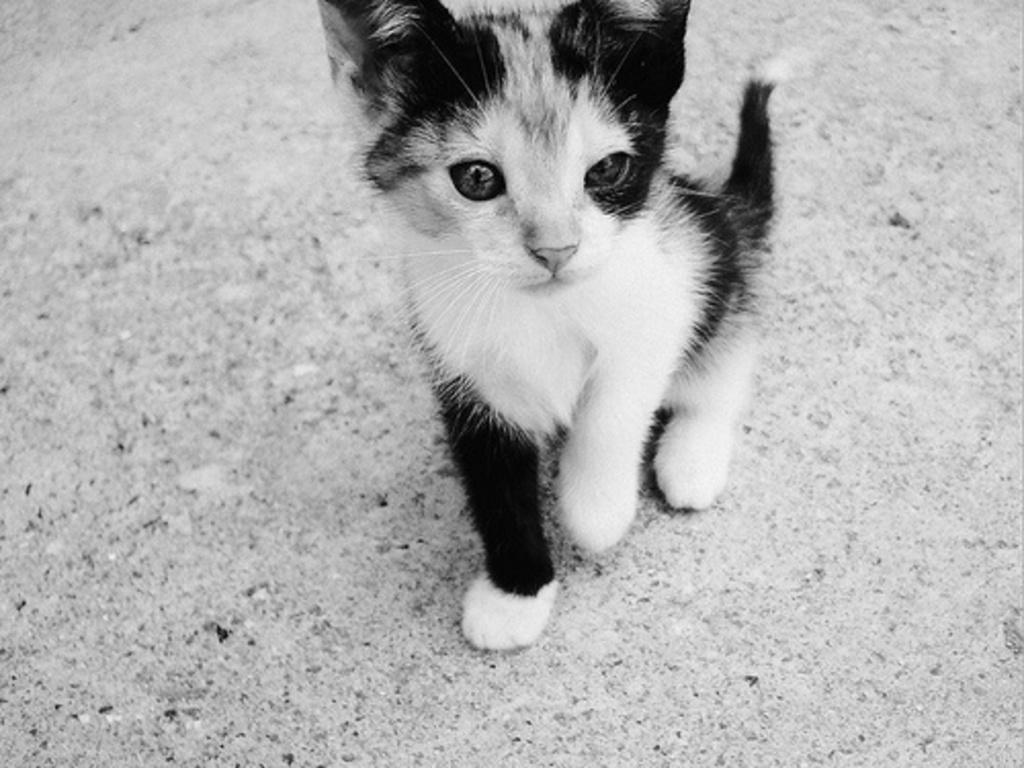What type of animal is in the image? There is a cat in the image. What is the cat doing or where is it located in the image? The cat is on a surface in the image. What type of watch is the cat wearing in the image? There is no watch present in the image, as the cat is not wearing any accessories. 